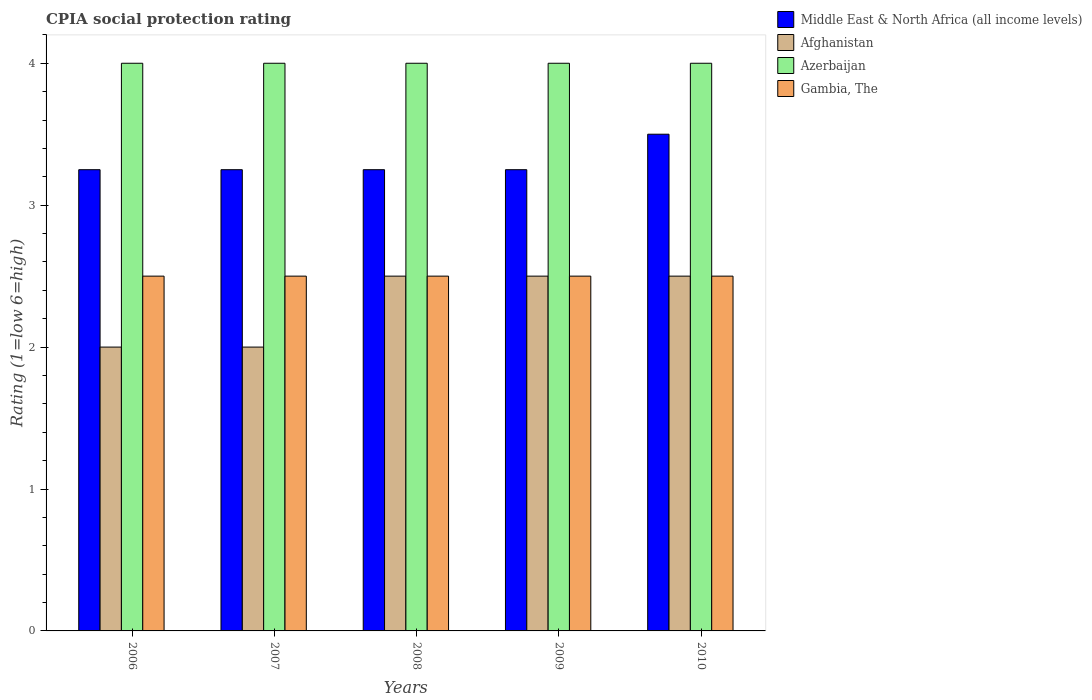How many different coloured bars are there?
Offer a terse response. 4. How many groups of bars are there?
Offer a very short reply. 5. Are the number of bars on each tick of the X-axis equal?
Keep it short and to the point. Yes. How many bars are there on the 2nd tick from the left?
Keep it short and to the point. 4. How many bars are there on the 1st tick from the right?
Your response must be concise. 4. Across all years, what is the maximum CPIA rating in Middle East & North Africa (all income levels)?
Keep it short and to the point. 3.5. Across all years, what is the minimum CPIA rating in Middle East & North Africa (all income levels)?
Provide a succinct answer. 3.25. In which year was the CPIA rating in Azerbaijan maximum?
Make the answer very short. 2006. What is the difference between the CPIA rating in Azerbaijan in 2008 and that in 2009?
Your response must be concise. 0. What is the difference between the CPIA rating in Azerbaijan in 2009 and the CPIA rating in Gambia, The in 2006?
Provide a succinct answer. 1.5. What is the average CPIA rating in Afghanistan per year?
Provide a succinct answer. 2.3. What is the ratio of the CPIA rating in Middle East & North Africa (all income levels) in 2007 to that in 2010?
Make the answer very short. 0.93. Is it the case that in every year, the sum of the CPIA rating in Gambia, The and CPIA rating in Afghanistan is greater than the sum of CPIA rating in Middle East & North Africa (all income levels) and CPIA rating in Azerbaijan?
Make the answer very short. No. What does the 1st bar from the left in 2010 represents?
Offer a terse response. Middle East & North Africa (all income levels). What does the 2nd bar from the right in 2009 represents?
Make the answer very short. Azerbaijan. Is it the case that in every year, the sum of the CPIA rating in Middle East & North Africa (all income levels) and CPIA rating in Gambia, The is greater than the CPIA rating in Afghanistan?
Your answer should be compact. Yes. How many bars are there?
Your answer should be compact. 20. Are all the bars in the graph horizontal?
Offer a terse response. No. Does the graph contain grids?
Your response must be concise. No. How many legend labels are there?
Offer a very short reply. 4. What is the title of the graph?
Provide a short and direct response. CPIA social protection rating. Does "Samoa" appear as one of the legend labels in the graph?
Keep it short and to the point. No. What is the label or title of the X-axis?
Provide a succinct answer. Years. What is the Rating (1=low 6=high) in Afghanistan in 2006?
Ensure brevity in your answer.  2. What is the Rating (1=low 6=high) in Middle East & North Africa (all income levels) in 2007?
Keep it short and to the point. 3.25. What is the Rating (1=low 6=high) of Afghanistan in 2007?
Offer a terse response. 2. What is the Rating (1=low 6=high) of Azerbaijan in 2007?
Give a very brief answer. 4. What is the Rating (1=low 6=high) of Afghanistan in 2010?
Offer a terse response. 2.5. What is the Rating (1=low 6=high) of Azerbaijan in 2010?
Make the answer very short. 4. What is the Rating (1=low 6=high) of Gambia, The in 2010?
Make the answer very short. 2.5. Across all years, what is the maximum Rating (1=low 6=high) in Middle East & North Africa (all income levels)?
Your answer should be compact. 3.5. Across all years, what is the maximum Rating (1=low 6=high) of Afghanistan?
Your answer should be very brief. 2.5. Across all years, what is the maximum Rating (1=low 6=high) in Azerbaijan?
Provide a succinct answer. 4. Across all years, what is the minimum Rating (1=low 6=high) in Afghanistan?
Offer a very short reply. 2. What is the total Rating (1=low 6=high) of Middle East & North Africa (all income levels) in the graph?
Give a very brief answer. 16.5. What is the difference between the Rating (1=low 6=high) in Gambia, The in 2006 and that in 2007?
Keep it short and to the point. 0. What is the difference between the Rating (1=low 6=high) in Afghanistan in 2006 and that in 2008?
Provide a short and direct response. -0.5. What is the difference between the Rating (1=low 6=high) of Middle East & North Africa (all income levels) in 2006 and that in 2009?
Make the answer very short. 0. What is the difference between the Rating (1=low 6=high) in Gambia, The in 2006 and that in 2009?
Offer a very short reply. 0. What is the difference between the Rating (1=low 6=high) of Afghanistan in 2006 and that in 2010?
Your response must be concise. -0.5. What is the difference between the Rating (1=low 6=high) in Middle East & North Africa (all income levels) in 2007 and that in 2008?
Keep it short and to the point. 0. What is the difference between the Rating (1=low 6=high) in Afghanistan in 2007 and that in 2009?
Keep it short and to the point. -0.5. What is the difference between the Rating (1=low 6=high) of Azerbaijan in 2007 and that in 2009?
Give a very brief answer. 0. What is the difference between the Rating (1=low 6=high) in Gambia, The in 2007 and that in 2009?
Your answer should be very brief. 0. What is the difference between the Rating (1=low 6=high) in Azerbaijan in 2007 and that in 2010?
Give a very brief answer. 0. What is the difference between the Rating (1=low 6=high) of Azerbaijan in 2008 and that in 2009?
Offer a very short reply. 0. What is the difference between the Rating (1=low 6=high) of Gambia, The in 2008 and that in 2010?
Offer a very short reply. 0. What is the difference between the Rating (1=low 6=high) in Gambia, The in 2009 and that in 2010?
Your answer should be very brief. 0. What is the difference between the Rating (1=low 6=high) of Middle East & North Africa (all income levels) in 2006 and the Rating (1=low 6=high) of Afghanistan in 2007?
Your response must be concise. 1.25. What is the difference between the Rating (1=low 6=high) in Middle East & North Africa (all income levels) in 2006 and the Rating (1=low 6=high) in Azerbaijan in 2007?
Make the answer very short. -0.75. What is the difference between the Rating (1=low 6=high) in Middle East & North Africa (all income levels) in 2006 and the Rating (1=low 6=high) in Gambia, The in 2007?
Your answer should be compact. 0.75. What is the difference between the Rating (1=low 6=high) of Afghanistan in 2006 and the Rating (1=low 6=high) of Gambia, The in 2007?
Make the answer very short. -0.5. What is the difference between the Rating (1=low 6=high) of Azerbaijan in 2006 and the Rating (1=low 6=high) of Gambia, The in 2007?
Your answer should be very brief. 1.5. What is the difference between the Rating (1=low 6=high) in Middle East & North Africa (all income levels) in 2006 and the Rating (1=low 6=high) in Azerbaijan in 2008?
Make the answer very short. -0.75. What is the difference between the Rating (1=low 6=high) of Middle East & North Africa (all income levels) in 2006 and the Rating (1=low 6=high) of Azerbaijan in 2009?
Make the answer very short. -0.75. What is the difference between the Rating (1=low 6=high) in Middle East & North Africa (all income levels) in 2006 and the Rating (1=low 6=high) in Gambia, The in 2009?
Provide a short and direct response. 0.75. What is the difference between the Rating (1=low 6=high) in Afghanistan in 2006 and the Rating (1=low 6=high) in Azerbaijan in 2009?
Keep it short and to the point. -2. What is the difference between the Rating (1=low 6=high) of Azerbaijan in 2006 and the Rating (1=low 6=high) of Gambia, The in 2009?
Ensure brevity in your answer.  1.5. What is the difference between the Rating (1=low 6=high) in Middle East & North Africa (all income levels) in 2006 and the Rating (1=low 6=high) in Afghanistan in 2010?
Your response must be concise. 0.75. What is the difference between the Rating (1=low 6=high) of Middle East & North Africa (all income levels) in 2006 and the Rating (1=low 6=high) of Azerbaijan in 2010?
Your answer should be very brief. -0.75. What is the difference between the Rating (1=low 6=high) of Afghanistan in 2006 and the Rating (1=low 6=high) of Gambia, The in 2010?
Provide a short and direct response. -0.5. What is the difference between the Rating (1=low 6=high) in Azerbaijan in 2006 and the Rating (1=low 6=high) in Gambia, The in 2010?
Your answer should be compact. 1.5. What is the difference between the Rating (1=low 6=high) in Middle East & North Africa (all income levels) in 2007 and the Rating (1=low 6=high) in Azerbaijan in 2008?
Keep it short and to the point. -0.75. What is the difference between the Rating (1=low 6=high) in Afghanistan in 2007 and the Rating (1=low 6=high) in Gambia, The in 2008?
Make the answer very short. -0.5. What is the difference between the Rating (1=low 6=high) in Azerbaijan in 2007 and the Rating (1=low 6=high) in Gambia, The in 2008?
Offer a very short reply. 1.5. What is the difference between the Rating (1=low 6=high) in Middle East & North Africa (all income levels) in 2007 and the Rating (1=low 6=high) in Afghanistan in 2009?
Make the answer very short. 0.75. What is the difference between the Rating (1=low 6=high) in Middle East & North Africa (all income levels) in 2007 and the Rating (1=low 6=high) in Azerbaijan in 2009?
Your answer should be very brief. -0.75. What is the difference between the Rating (1=low 6=high) in Middle East & North Africa (all income levels) in 2007 and the Rating (1=low 6=high) in Gambia, The in 2009?
Offer a terse response. 0.75. What is the difference between the Rating (1=low 6=high) in Afghanistan in 2007 and the Rating (1=low 6=high) in Azerbaijan in 2009?
Ensure brevity in your answer.  -2. What is the difference between the Rating (1=low 6=high) of Azerbaijan in 2007 and the Rating (1=low 6=high) of Gambia, The in 2009?
Offer a very short reply. 1.5. What is the difference between the Rating (1=low 6=high) in Middle East & North Africa (all income levels) in 2007 and the Rating (1=low 6=high) in Azerbaijan in 2010?
Your answer should be compact. -0.75. What is the difference between the Rating (1=low 6=high) in Middle East & North Africa (all income levels) in 2007 and the Rating (1=low 6=high) in Gambia, The in 2010?
Offer a terse response. 0.75. What is the difference between the Rating (1=low 6=high) in Middle East & North Africa (all income levels) in 2008 and the Rating (1=low 6=high) in Afghanistan in 2009?
Offer a very short reply. 0.75. What is the difference between the Rating (1=low 6=high) in Middle East & North Africa (all income levels) in 2008 and the Rating (1=low 6=high) in Azerbaijan in 2009?
Provide a succinct answer. -0.75. What is the difference between the Rating (1=low 6=high) of Middle East & North Africa (all income levels) in 2008 and the Rating (1=low 6=high) of Gambia, The in 2009?
Your answer should be compact. 0.75. What is the difference between the Rating (1=low 6=high) of Afghanistan in 2008 and the Rating (1=low 6=high) of Gambia, The in 2009?
Your answer should be compact. 0. What is the difference between the Rating (1=low 6=high) of Middle East & North Africa (all income levels) in 2008 and the Rating (1=low 6=high) of Afghanistan in 2010?
Provide a short and direct response. 0.75. What is the difference between the Rating (1=low 6=high) of Middle East & North Africa (all income levels) in 2008 and the Rating (1=low 6=high) of Azerbaijan in 2010?
Your response must be concise. -0.75. What is the difference between the Rating (1=low 6=high) of Middle East & North Africa (all income levels) in 2008 and the Rating (1=low 6=high) of Gambia, The in 2010?
Ensure brevity in your answer.  0.75. What is the difference between the Rating (1=low 6=high) of Afghanistan in 2008 and the Rating (1=low 6=high) of Azerbaijan in 2010?
Your answer should be very brief. -1.5. What is the difference between the Rating (1=low 6=high) of Azerbaijan in 2008 and the Rating (1=low 6=high) of Gambia, The in 2010?
Ensure brevity in your answer.  1.5. What is the difference between the Rating (1=low 6=high) of Middle East & North Africa (all income levels) in 2009 and the Rating (1=low 6=high) of Afghanistan in 2010?
Offer a terse response. 0.75. What is the difference between the Rating (1=low 6=high) of Middle East & North Africa (all income levels) in 2009 and the Rating (1=low 6=high) of Azerbaijan in 2010?
Give a very brief answer. -0.75. What is the difference between the Rating (1=low 6=high) of Middle East & North Africa (all income levels) in 2009 and the Rating (1=low 6=high) of Gambia, The in 2010?
Offer a very short reply. 0.75. What is the difference between the Rating (1=low 6=high) in Afghanistan in 2009 and the Rating (1=low 6=high) in Azerbaijan in 2010?
Give a very brief answer. -1.5. What is the difference between the Rating (1=low 6=high) of Afghanistan in 2009 and the Rating (1=low 6=high) of Gambia, The in 2010?
Keep it short and to the point. 0. What is the difference between the Rating (1=low 6=high) of Azerbaijan in 2009 and the Rating (1=low 6=high) of Gambia, The in 2010?
Keep it short and to the point. 1.5. What is the average Rating (1=low 6=high) of Middle East & North Africa (all income levels) per year?
Give a very brief answer. 3.3. What is the average Rating (1=low 6=high) of Azerbaijan per year?
Your answer should be very brief. 4. What is the average Rating (1=low 6=high) in Gambia, The per year?
Make the answer very short. 2.5. In the year 2006, what is the difference between the Rating (1=low 6=high) of Middle East & North Africa (all income levels) and Rating (1=low 6=high) of Afghanistan?
Give a very brief answer. 1.25. In the year 2006, what is the difference between the Rating (1=low 6=high) in Middle East & North Africa (all income levels) and Rating (1=low 6=high) in Azerbaijan?
Give a very brief answer. -0.75. In the year 2006, what is the difference between the Rating (1=low 6=high) in Middle East & North Africa (all income levels) and Rating (1=low 6=high) in Gambia, The?
Make the answer very short. 0.75. In the year 2007, what is the difference between the Rating (1=low 6=high) of Middle East & North Africa (all income levels) and Rating (1=low 6=high) of Azerbaijan?
Provide a short and direct response. -0.75. In the year 2008, what is the difference between the Rating (1=low 6=high) of Middle East & North Africa (all income levels) and Rating (1=low 6=high) of Azerbaijan?
Provide a short and direct response. -0.75. In the year 2008, what is the difference between the Rating (1=low 6=high) in Afghanistan and Rating (1=low 6=high) in Azerbaijan?
Provide a succinct answer. -1.5. In the year 2008, what is the difference between the Rating (1=low 6=high) of Afghanistan and Rating (1=low 6=high) of Gambia, The?
Your response must be concise. 0. In the year 2008, what is the difference between the Rating (1=low 6=high) in Azerbaijan and Rating (1=low 6=high) in Gambia, The?
Provide a short and direct response. 1.5. In the year 2009, what is the difference between the Rating (1=low 6=high) of Middle East & North Africa (all income levels) and Rating (1=low 6=high) of Afghanistan?
Ensure brevity in your answer.  0.75. In the year 2009, what is the difference between the Rating (1=low 6=high) in Middle East & North Africa (all income levels) and Rating (1=low 6=high) in Azerbaijan?
Offer a very short reply. -0.75. In the year 2009, what is the difference between the Rating (1=low 6=high) in Azerbaijan and Rating (1=low 6=high) in Gambia, The?
Your answer should be compact. 1.5. In the year 2010, what is the difference between the Rating (1=low 6=high) in Middle East & North Africa (all income levels) and Rating (1=low 6=high) in Afghanistan?
Keep it short and to the point. 1. In the year 2010, what is the difference between the Rating (1=low 6=high) of Afghanistan and Rating (1=low 6=high) of Gambia, The?
Your answer should be very brief. 0. In the year 2010, what is the difference between the Rating (1=low 6=high) in Azerbaijan and Rating (1=low 6=high) in Gambia, The?
Offer a terse response. 1.5. What is the ratio of the Rating (1=low 6=high) of Afghanistan in 2006 to that in 2007?
Offer a very short reply. 1. What is the ratio of the Rating (1=low 6=high) in Azerbaijan in 2006 to that in 2007?
Give a very brief answer. 1. What is the ratio of the Rating (1=low 6=high) in Gambia, The in 2006 to that in 2007?
Ensure brevity in your answer.  1. What is the ratio of the Rating (1=low 6=high) of Middle East & North Africa (all income levels) in 2006 to that in 2008?
Give a very brief answer. 1. What is the ratio of the Rating (1=low 6=high) in Afghanistan in 2006 to that in 2008?
Keep it short and to the point. 0.8. What is the ratio of the Rating (1=low 6=high) in Azerbaijan in 2006 to that in 2008?
Ensure brevity in your answer.  1. What is the ratio of the Rating (1=low 6=high) of Azerbaijan in 2006 to that in 2009?
Give a very brief answer. 1. What is the ratio of the Rating (1=low 6=high) of Gambia, The in 2006 to that in 2009?
Keep it short and to the point. 1. What is the ratio of the Rating (1=low 6=high) of Middle East & North Africa (all income levels) in 2006 to that in 2010?
Provide a succinct answer. 0.93. What is the ratio of the Rating (1=low 6=high) of Afghanistan in 2006 to that in 2010?
Your answer should be compact. 0.8. What is the ratio of the Rating (1=low 6=high) of Azerbaijan in 2006 to that in 2010?
Offer a very short reply. 1. What is the ratio of the Rating (1=low 6=high) in Gambia, The in 2006 to that in 2010?
Ensure brevity in your answer.  1. What is the ratio of the Rating (1=low 6=high) in Middle East & North Africa (all income levels) in 2007 to that in 2009?
Offer a very short reply. 1. What is the ratio of the Rating (1=low 6=high) in Afghanistan in 2007 to that in 2010?
Your response must be concise. 0.8. What is the ratio of the Rating (1=low 6=high) of Azerbaijan in 2007 to that in 2010?
Provide a succinct answer. 1. What is the ratio of the Rating (1=low 6=high) in Middle East & North Africa (all income levels) in 2008 to that in 2009?
Keep it short and to the point. 1. What is the ratio of the Rating (1=low 6=high) of Afghanistan in 2008 to that in 2009?
Provide a succinct answer. 1. What is the ratio of the Rating (1=low 6=high) of Middle East & North Africa (all income levels) in 2008 to that in 2010?
Your answer should be very brief. 0.93. What is the ratio of the Rating (1=low 6=high) in Afghanistan in 2008 to that in 2010?
Your answer should be very brief. 1. What is the ratio of the Rating (1=low 6=high) of Gambia, The in 2009 to that in 2010?
Give a very brief answer. 1. What is the difference between the highest and the second highest Rating (1=low 6=high) of Middle East & North Africa (all income levels)?
Give a very brief answer. 0.25. What is the difference between the highest and the second highest Rating (1=low 6=high) of Azerbaijan?
Keep it short and to the point. 0. What is the difference between the highest and the lowest Rating (1=low 6=high) in Azerbaijan?
Your response must be concise. 0. What is the difference between the highest and the lowest Rating (1=low 6=high) in Gambia, The?
Your response must be concise. 0. 